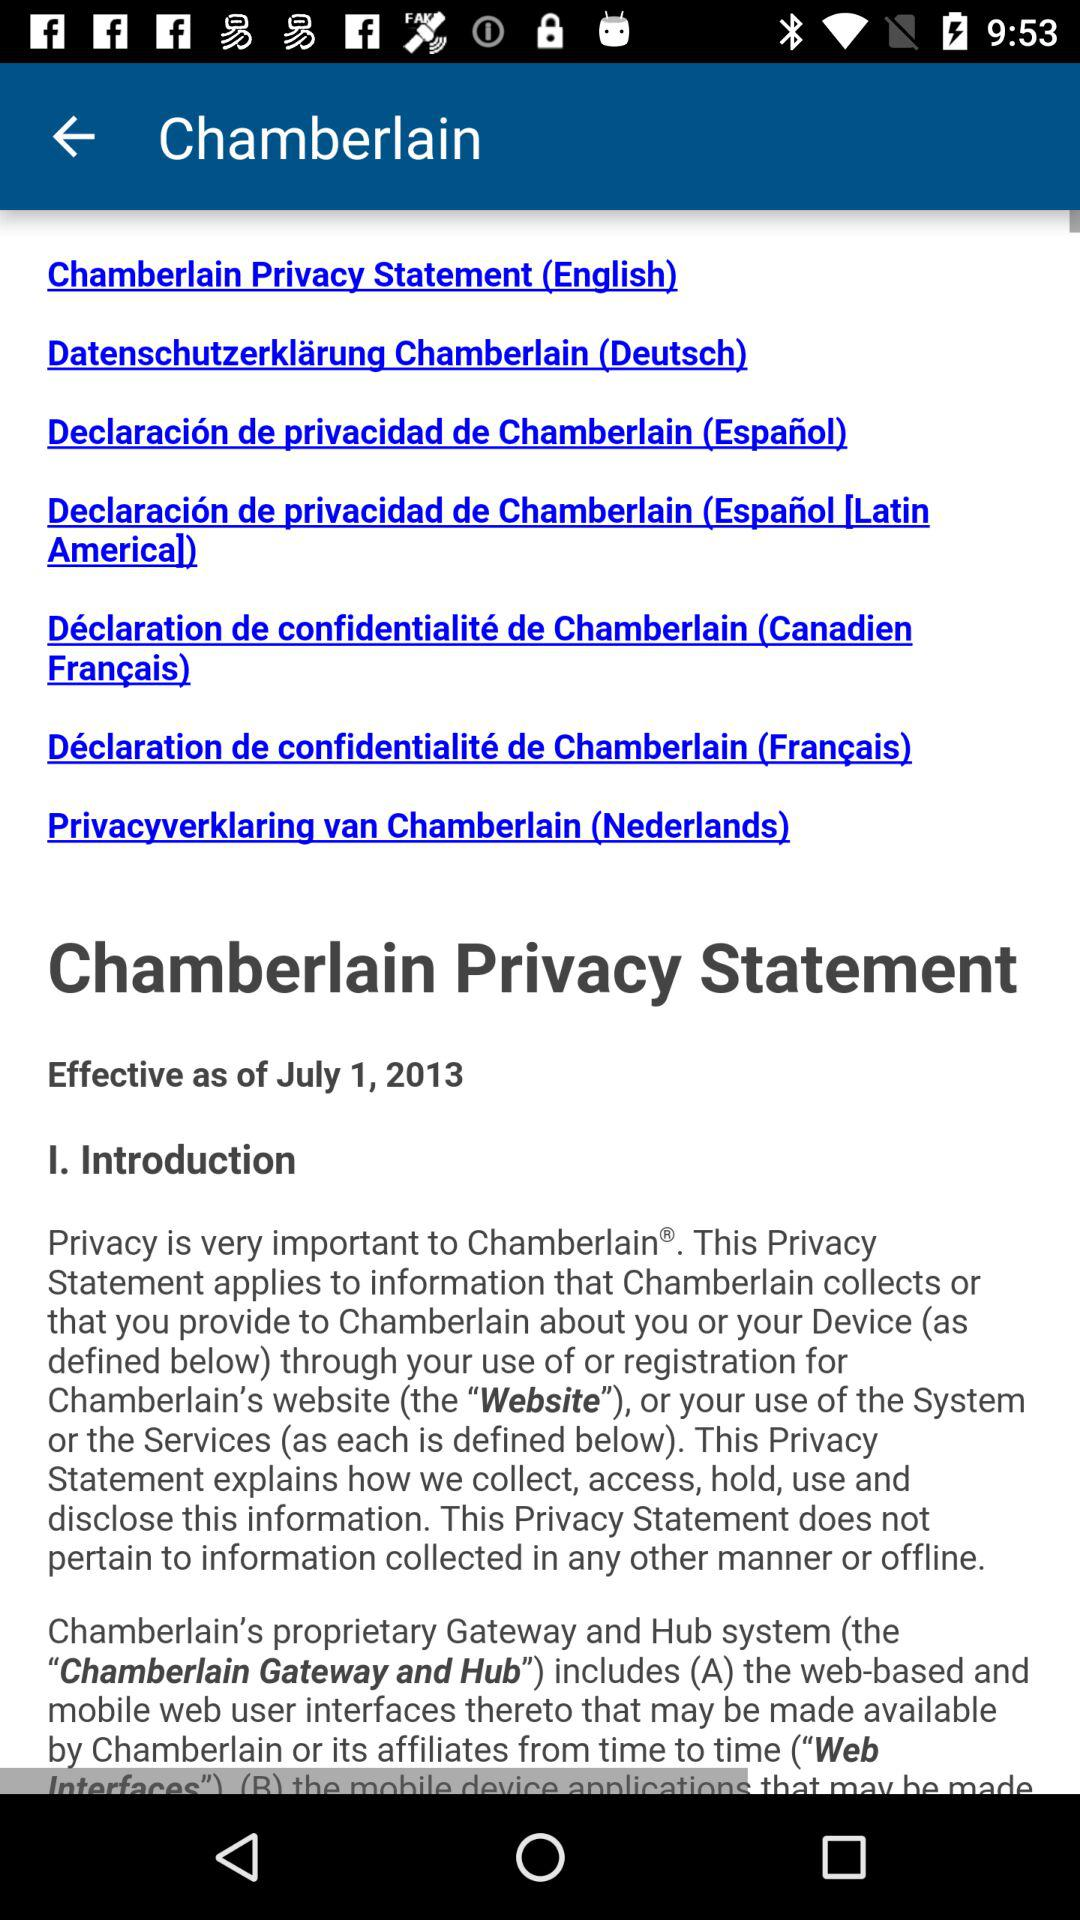How many languages are available in the privacy statement?
Answer the question using a single word or phrase. 7 